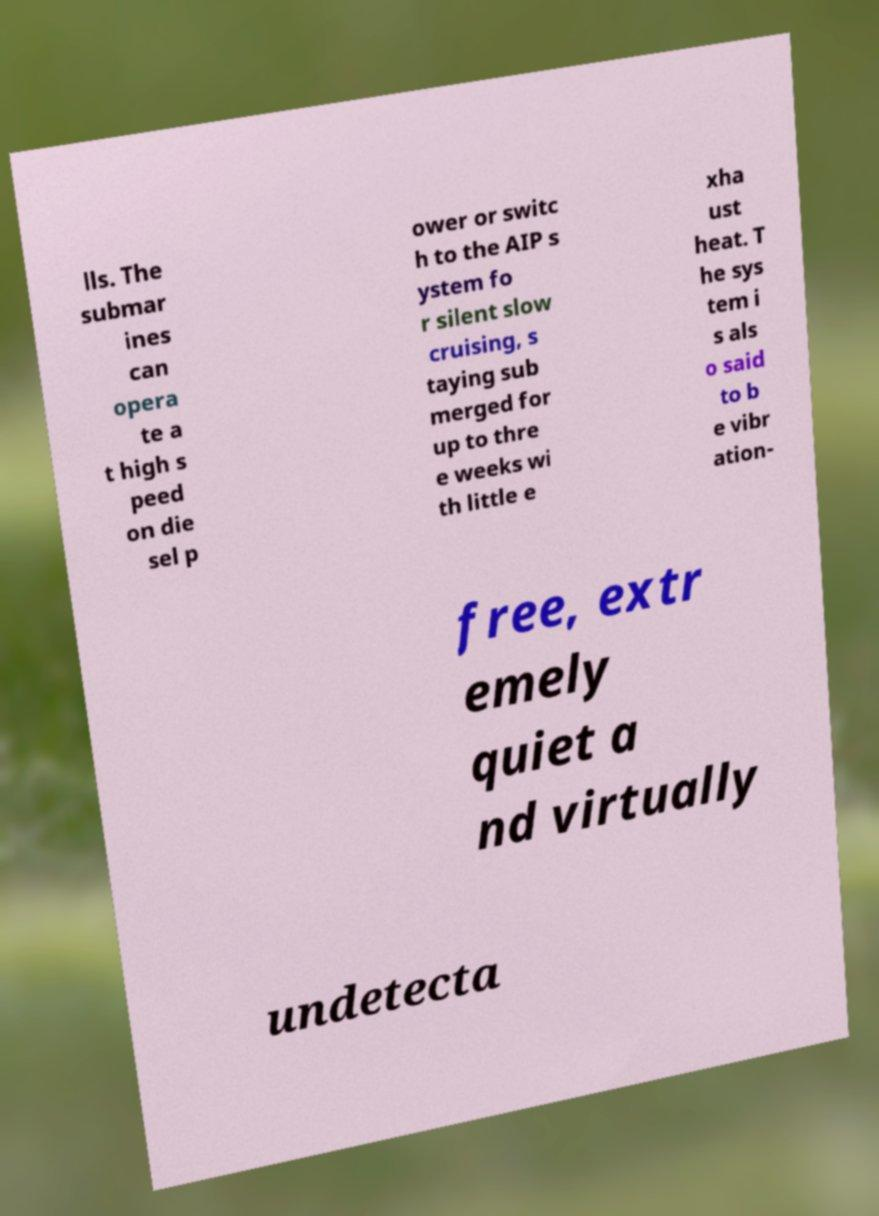What messages or text are displayed in this image? I need them in a readable, typed format. lls. The submar ines can opera te a t high s peed on die sel p ower or switc h to the AIP s ystem fo r silent slow cruising, s taying sub merged for up to thre e weeks wi th little e xha ust heat. T he sys tem i s als o said to b e vibr ation- free, extr emely quiet a nd virtually undetecta 